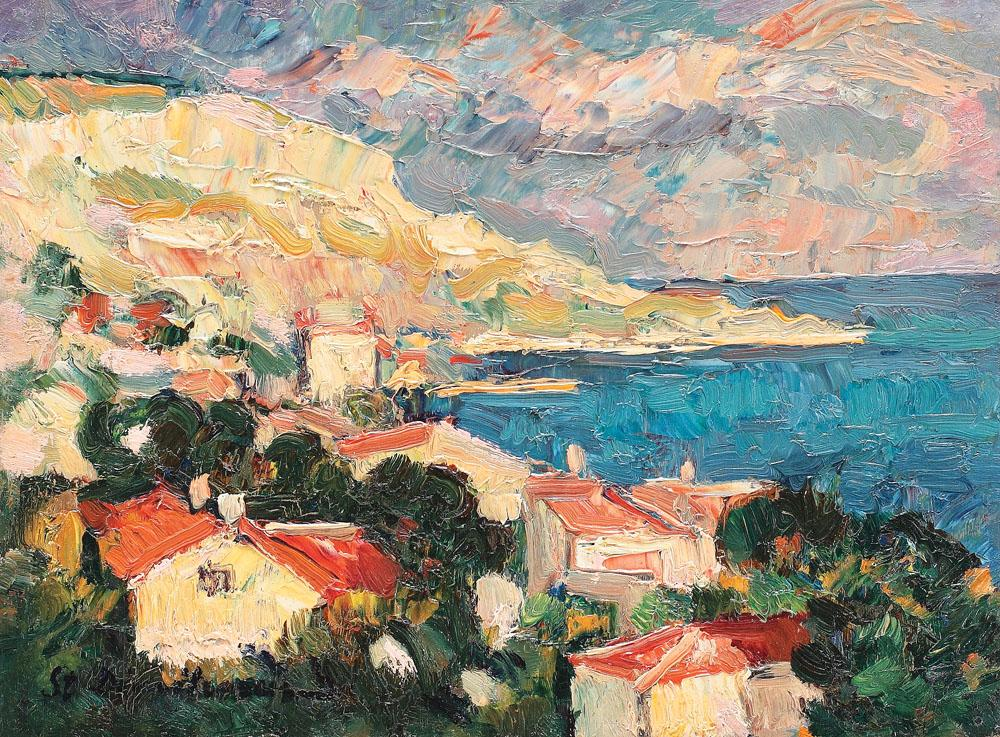What are the key elements in this picture? This image vividly brings to life an impressionist coastal landscape captured in oil on canvas, a medium celebrated for its rich texture and vibrant color treatment. The key elements include the distinct, red-roofed houses which are nestled amidst verdant foliage and positioned against a dramatic cliff backdrop, suggesting a harmonious blend of human habitation within a rugged natural environment. The sea is rendered in striking shades of blue, which gently contrast with the sky's dynamic mix of pink, orange, and blue hues, likely indicating a time of day that captures either a serene sunrise or a tranquil sunset. This painting is quintessentially impressionist, characterized by a focus on light and color dynamics, ultimately evoking a sense of place that is both timeless and vividly present. 